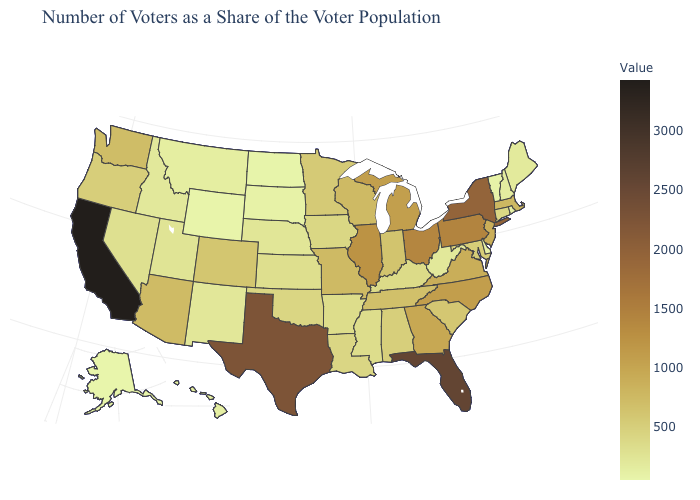Among the states that border South Dakota , does Wyoming have the lowest value?
Answer briefly. Yes. Does California have the highest value in the USA?
Concise answer only. Yes. Which states have the highest value in the USA?
Keep it brief. California. Is the legend a continuous bar?
Short answer required. Yes. Does Colorado have the highest value in the USA?
Write a very short answer. No. 